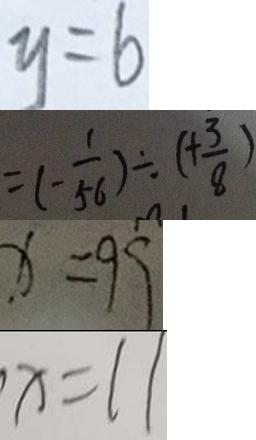Convert formula to latex. <formula><loc_0><loc_0><loc_500><loc_500>y = 6 
 = ( - \frac { 1 } { 5 6 } ) \div ( + \frac { 3 } { 8 } ) 
 x = 9 9 
 x = 1 1</formula> 